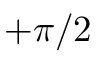Convert formula to latex. <formula><loc_0><loc_0><loc_500><loc_500>+ \pi / 2</formula> 